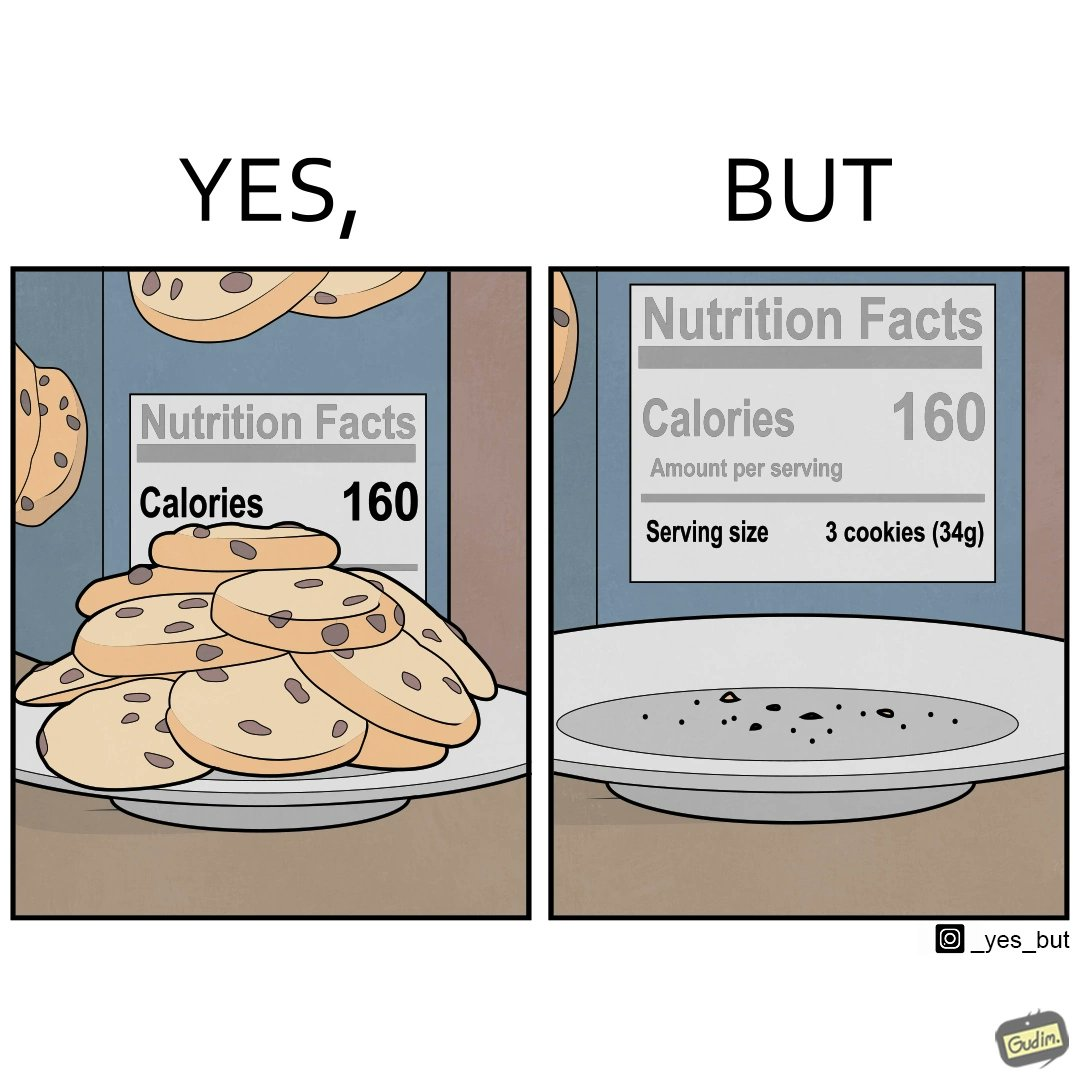Provide a description of this image. The image is funny because the full plate of cookies is hiding the entire nutrition facts leading readers to believe that the entire box of cookies amounts to just 160 calories but when all the cookies are eaten and the plate is empty, the rest of the nutrition table is visible which tells that each serving of cookies amounts to 160 calories where one serving consists of 3 cookies. 